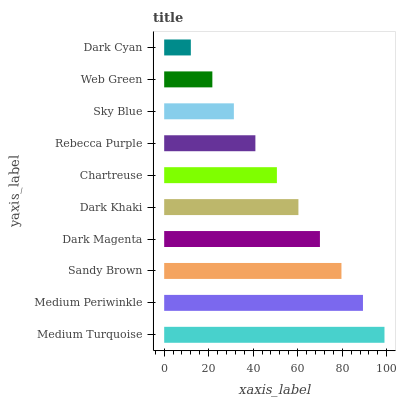Is Dark Cyan the minimum?
Answer yes or no. Yes. Is Medium Turquoise the maximum?
Answer yes or no. Yes. Is Medium Periwinkle the minimum?
Answer yes or no. No. Is Medium Periwinkle the maximum?
Answer yes or no. No. Is Medium Turquoise greater than Medium Periwinkle?
Answer yes or no. Yes. Is Medium Periwinkle less than Medium Turquoise?
Answer yes or no. Yes. Is Medium Periwinkle greater than Medium Turquoise?
Answer yes or no. No. Is Medium Turquoise less than Medium Periwinkle?
Answer yes or no. No. Is Dark Khaki the high median?
Answer yes or no. Yes. Is Chartreuse the low median?
Answer yes or no. Yes. Is Sky Blue the high median?
Answer yes or no. No. Is Medium Turquoise the low median?
Answer yes or no. No. 